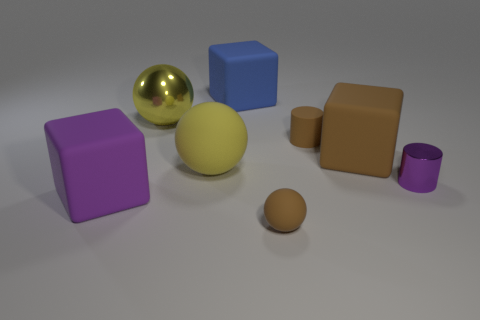How many other objects are there of the same shape as the large purple thing?
Your answer should be compact. 2. What is the color of the big rubber block that is behind the large purple matte cube and left of the tiny brown ball?
Ensure brevity in your answer.  Blue. Do the metal thing that is to the left of the small purple thing and the big matte ball have the same color?
Ensure brevity in your answer.  Yes. What number of cubes are brown metal things or big purple matte objects?
Keep it short and to the point. 1. What shape is the small matte thing that is in front of the small purple metallic cylinder?
Provide a short and direct response. Sphere. What is the color of the matte block that is behind the matte thing to the right of the small brown matte object behind the brown sphere?
Ensure brevity in your answer.  Blue. Does the tiny ball have the same material as the big brown cube?
Give a very brief answer. Yes. What number of yellow objects are either big shiny objects or matte cylinders?
Your answer should be very brief. 1. What number of big purple things are right of the tiny purple thing?
Provide a short and direct response. 0. Are there more yellow balls than green blocks?
Provide a succinct answer. Yes. 